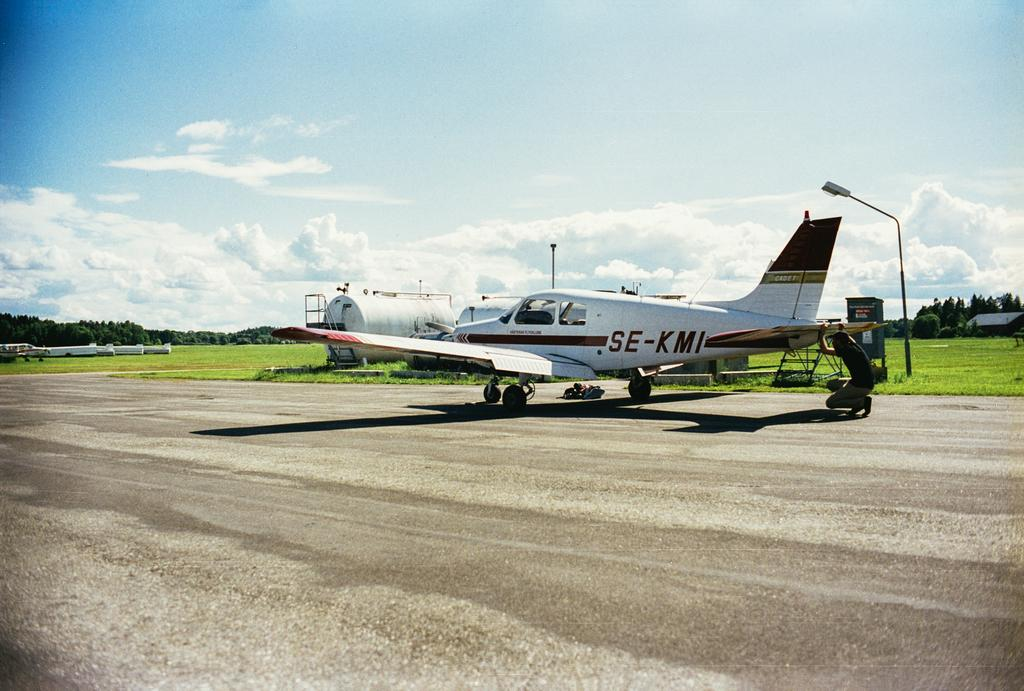<image>
Render a clear and concise summary of the photo. An airplane is on a runway with SE-KMI on the side of it. 